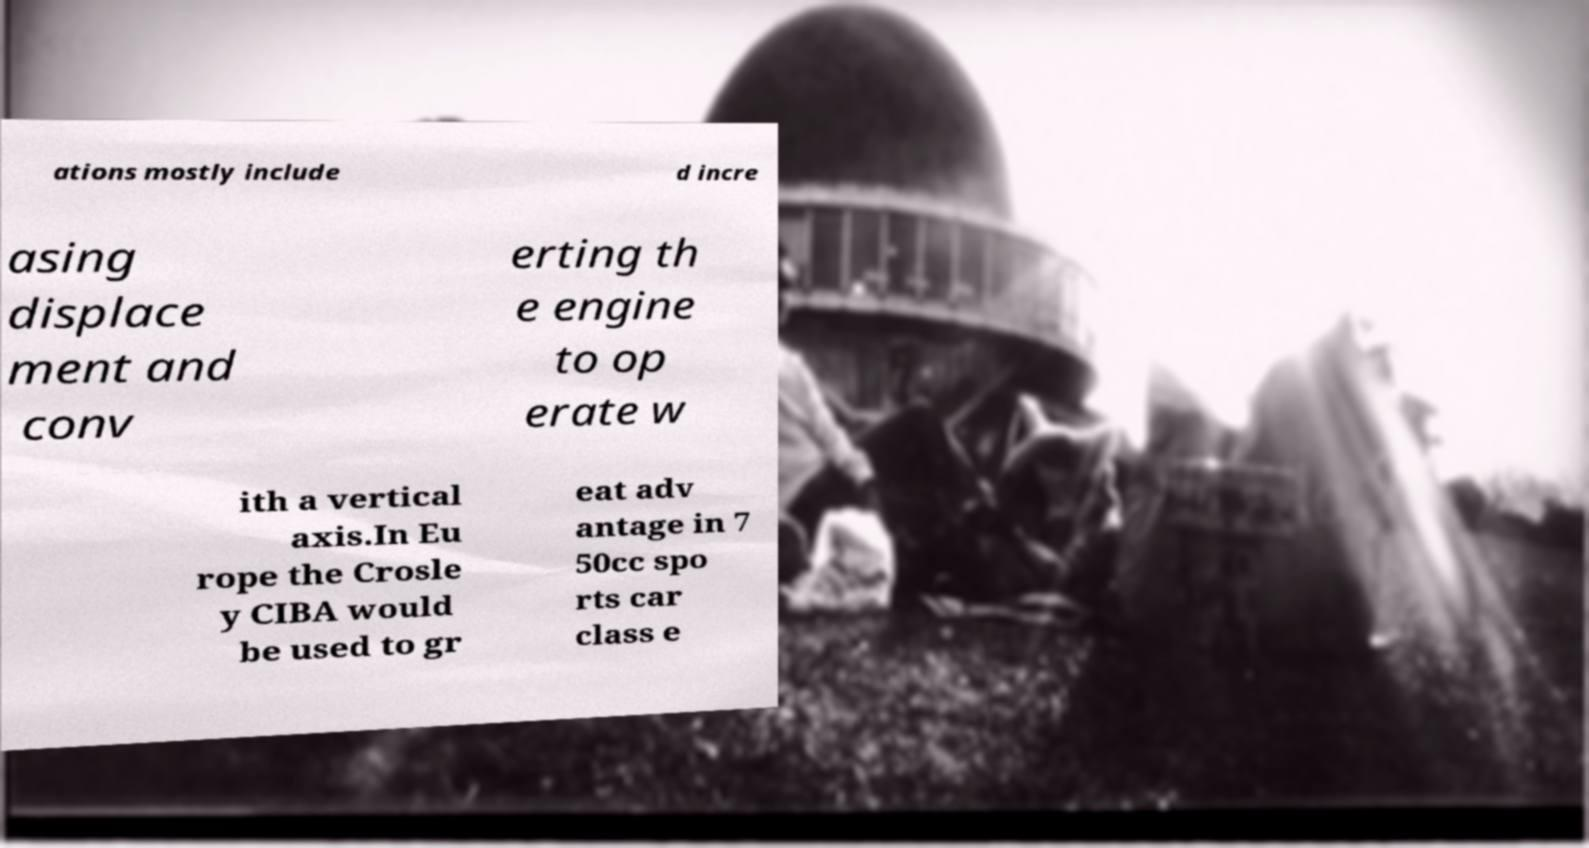For documentation purposes, I need the text within this image transcribed. Could you provide that? ations mostly include d incre asing displace ment and conv erting th e engine to op erate w ith a vertical axis.In Eu rope the Crosle y CIBA would be used to gr eat adv antage in 7 50cc spo rts car class e 